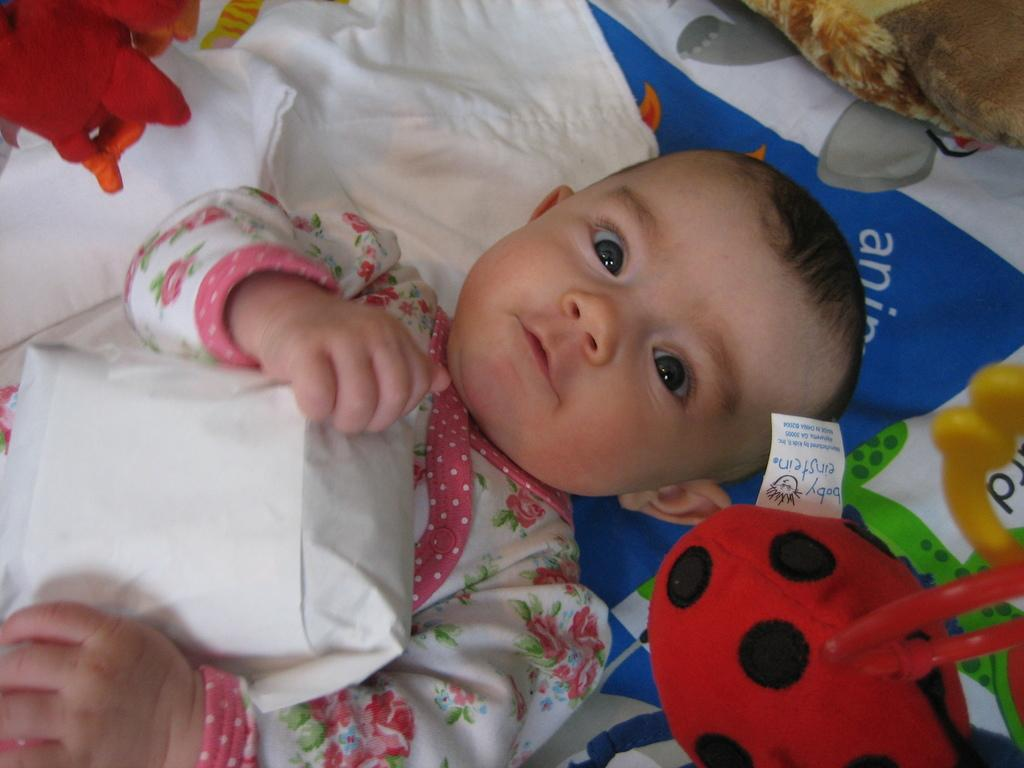What is the main subject of the image? There is a baby in the image. What else can be seen in the image besides the baby? There are toys on a cloth in the image. Can you describe the toys or the cloth in the image? Unfortunately, the facts provided do not specify the type of toys or the appearance of the cloth. What type of marble is being used to solve the riddle in the image? There is no marble or riddle present in the image; it features a baby and toys on a cloth. What flavor of jelly is being served to the baby in the image? There is no jelly present in the image; it features a baby and toys on a cloth. 